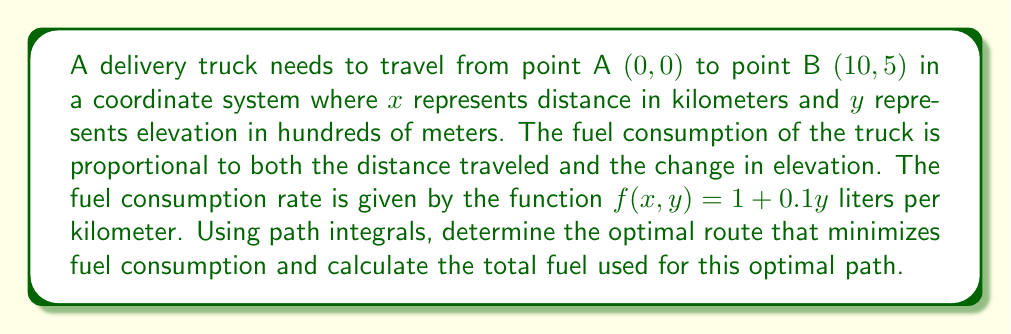Can you answer this question? To solve this problem, we'll use the calculus of variations and path integrals. The steps are as follows:

1) The fuel consumption along a path $y(x)$ is given by the path integral:

   $$I = \int_0^{10} (1 + 0.1y) \sqrt{1 + (y')^2} dx$$

   where $y'$ is the derivative of $y$ with respect to $x$.

2) To minimize this integral, we use the Euler-Lagrange equation:

   $$\frac{\partial F}{\partial y} - \frac{d}{dx}\frac{\partial F}{\partial y'} = 0$$

   where $F = (1 + 0.1y) \sqrt{1 + (y')^2}$

3) Calculating the partial derivatives:

   $$\frac{\partial F}{\partial y} = 0.1\sqrt{1 + (y')^2}$$
   $$\frac{\partial F}{\partial y'} = \frac{(1 + 0.1y)y'}{\sqrt{1 + (y')^2}}$$

4) Substituting into the Euler-Lagrange equation:

   $$0.1\sqrt{1 + (y')^2} - \frac{d}{dx}\left(\frac{(1 + 0.1y)y'}{\sqrt{1 + (y')^2}}\right) = 0$$

5) This differential equation simplifies to:

   $$y'' = 0$$

6) The solution to this equation is a straight line:

   $$y = mx + b$$

7) Using the boundary conditions $y(0) = 0$ and $y(10) = 5$, we find:

   $$m = 0.5, b = 0$$

   So the optimal path is $y = 0.5x$

8) To calculate the total fuel consumption, we integrate along this path:

   $$I = \int_0^{10} (1 + 0.1(0.5x)) \sqrt{1 + 0.5^2} dx$$
   $$= \sqrt{1.25} \int_0^{10} (1 + 0.05x) dx$$
   $$= \sqrt{1.25} [x + 0.025x^2]_0^{10}$$
   $$= \sqrt{1.25} (10 + 2.5) = 14.03 \text{ liters}$$
Answer: 14.03 liters 